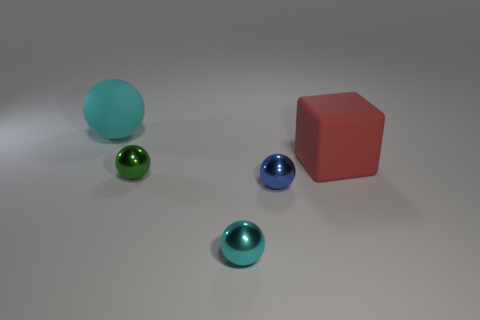There is a cyan object to the left of the small cyan sphere; how many tiny things are in front of it?
Your response must be concise. 3. Are there any other things that are made of the same material as the cube?
Give a very brief answer. Yes. How many things are either cyan things that are behind the tiny cyan shiny thing or large yellow metallic spheres?
Provide a succinct answer. 1. There is a cyan ball on the left side of the green metallic object; what size is it?
Keep it short and to the point. Large. What material is the large red block?
Provide a succinct answer. Rubber. The big object that is to the left of the cyan sphere in front of the big block is what shape?
Give a very brief answer. Sphere. How many other objects are the same shape as the small cyan metal thing?
Your answer should be compact. 3. Are there any cyan matte objects to the right of the green sphere?
Ensure brevity in your answer.  No. What is the color of the big cube?
Provide a short and direct response. Red. Do the large ball and the large object that is right of the matte sphere have the same color?
Make the answer very short. No. 